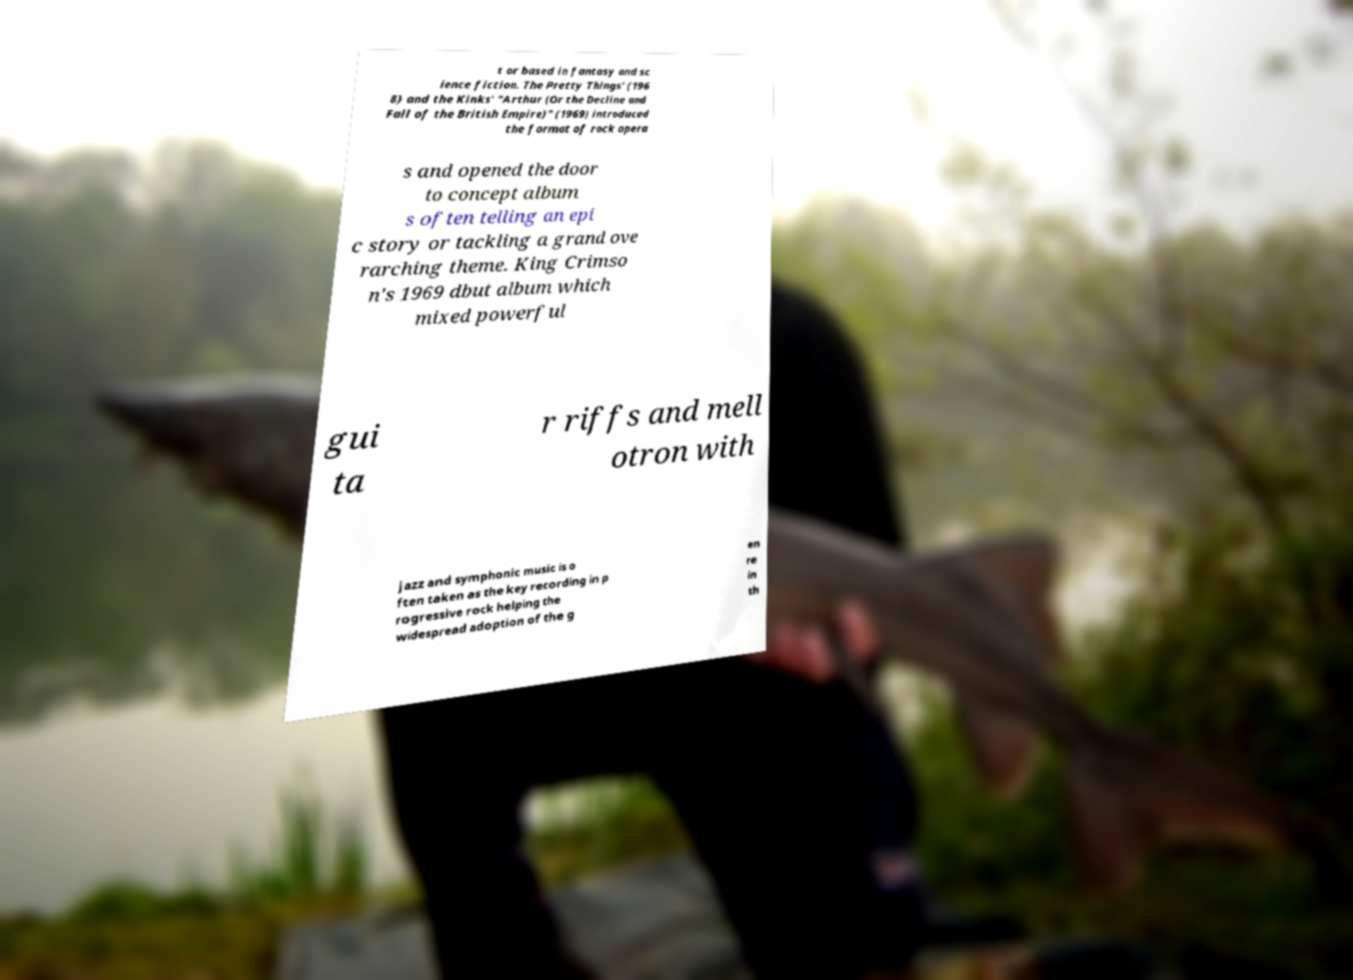Can you read and provide the text displayed in the image?This photo seems to have some interesting text. Can you extract and type it out for me? t or based in fantasy and sc ience fiction. The Pretty Things' (196 8) and the Kinks' "Arthur (Or the Decline and Fall of the British Empire)" (1969) introduced the format of rock opera s and opened the door to concept album s often telling an epi c story or tackling a grand ove rarching theme. King Crimso n's 1969 dbut album which mixed powerful gui ta r riffs and mell otron with jazz and symphonic music is o ften taken as the key recording in p rogressive rock helping the widespread adoption of the g en re in th 